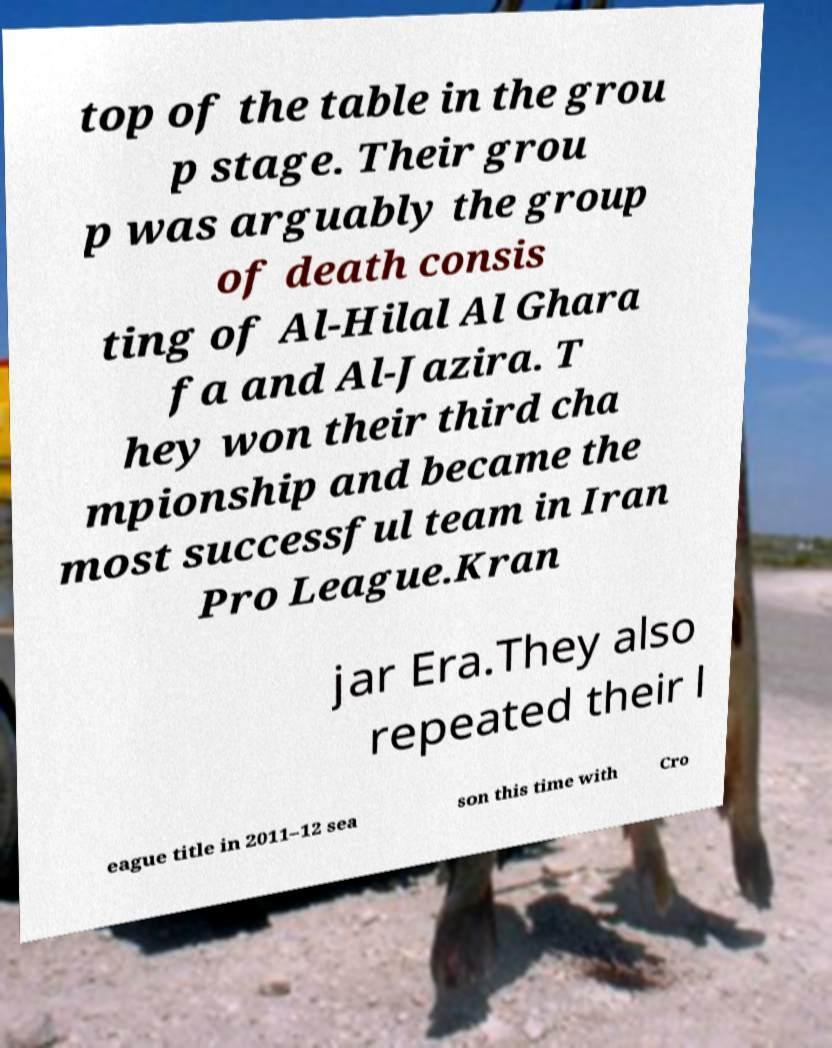For documentation purposes, I need the text within this image transcribed. Could you provide that? top of the table in the grou p stage. Their grou p was arguably the group of death consis ting of Al-Hilal Al Ghara fa and Al-Jazira. T hey won their third cha mpionship and became the most successful team in Iran Pro League.Kran jar Era.They also repeated their l eague title in 2011–12 sea son this time with Cro 